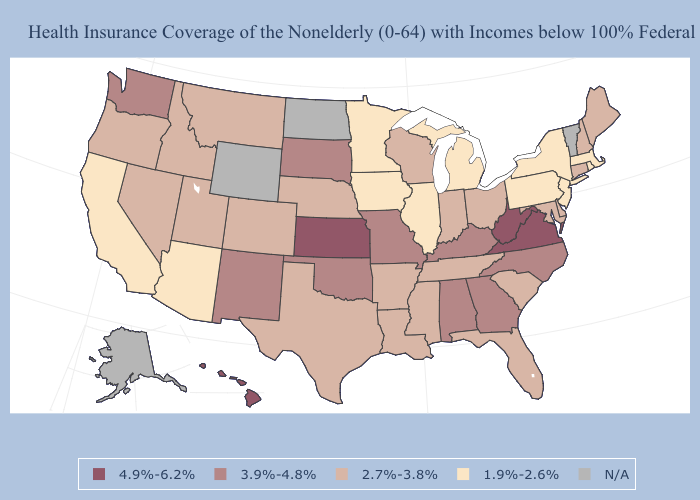Does the map have missing data?
Keep it brief. Yes. Name the states that have a value in the range 4.9%-6.2%?
Answer briefly. Hawaii, Kansas, Virginia, West Virginia. Name the states that have a value in the range 1.9%-2.6%?
Write a very short answer. Arizona, California, Illinois, Iowa, Massachusetts, Michigan, Minnesota, New Jersey, New York, Pennsylvania, Rhode Island. What is the value of Wisconsin?
Short answer required. 2.7%-3.8%. How many symbols are there in the legend?
Write a very short answer. 5. What is the lowest value in the USA?
Give a very brief answer. 1.9%-2.6%. Does the first symbol in the legend represent the smallest category?
Quick response, please. No. Name the states that have a value in the range 2.7%-3.8%?
Keep it brief. Arkansas, Colorado, Connecticut, Delaware, Florida, Idaho, Indiana, Louisiana, Maine, Maryland, Mississippi, Montana, Nebraska, Nevada, New Hampshire, Ohio, Oregon, South Carolina, Tennessee, Texas, Utah, Wisconsin. What is the value of Colorado?
Short answer required. 2.7%-3.8%. What is the value of Alaska?
Concise answer only. N/A. Is the legend a continuous bar?
Write a very short answer. No. Among the states that border Mississippi , does Alabama have the lowest value?
Answer briefly. No. Which states have the lowest value in the West?
Write a very short answer. Arizona, California. What is the value of Kentucky?
Be succinct. 3.9%-4.8%. What is the lowest value in the USA?
Write a very short answer. 1.9%-2.6%. 